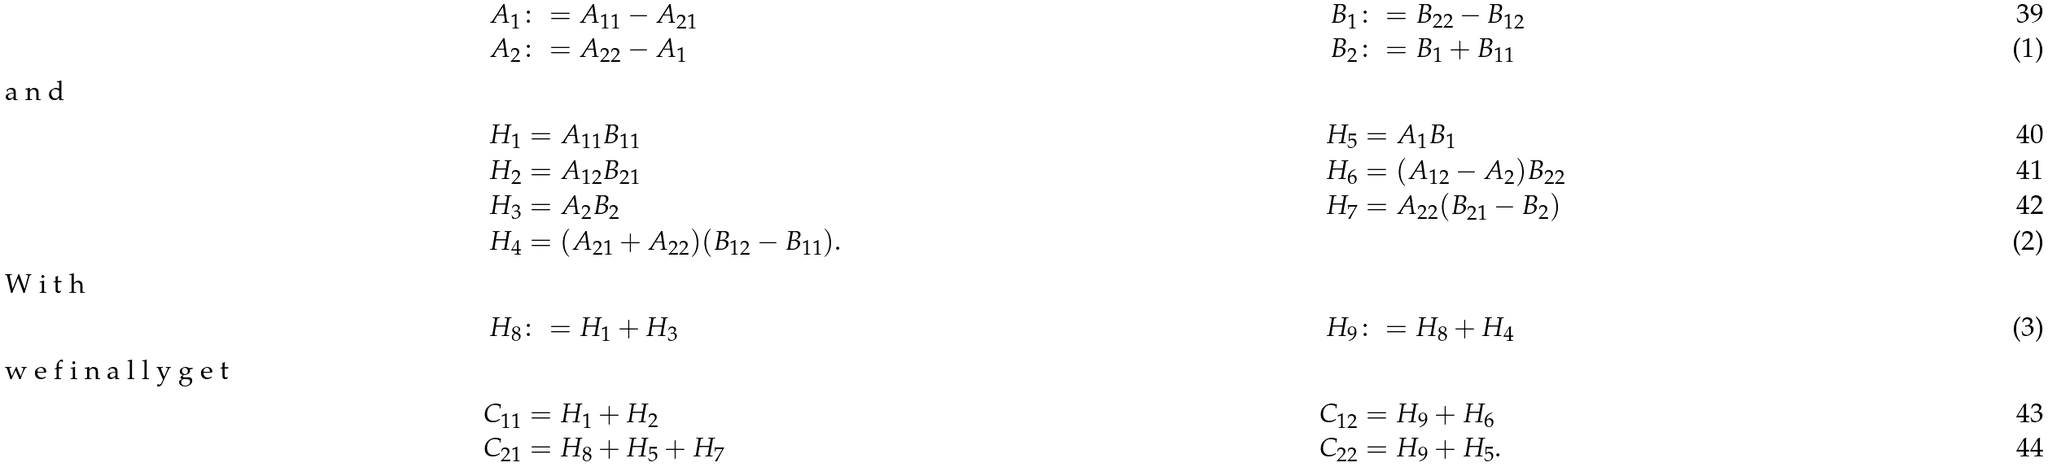Convert formula to latex. <formula><loc_0><loc_0><loc_500><loc_500>A _ { 1 } & \colon = A _ { 1 1 } - A _ { 2 1 } & B _ { 1 } & \colon = B _ { 2 2 } - B _ { 1 2 } \\ A _ { 2 } & \colon = A _ { 2 2 } - A _ { 1 } & B _ { 2 } & \colon = B _ { 1 } + B _ { 1 1 } \intertext { a n d } H _ { 1 } & = A _ { 1 1 } B _ { 1 1 } & H _ { 5 } & = A _ { 1 } B _ { 1 } \\ H _ { 2 } & = A _ { 1 2 } B _ { 2 1 } & H _ { 6 } & = ( A _ { 1 2 } - A _ { 2 } ) B _ { 2 2 } \\ H _ { 3 } & = A _ { 2 } B _ { 2 } & H _ { 7 } & = A _ { 2 2 } ( B _ { 2 1 } - B _ { 2 } ) \\ H _ { 4 } & = ( A _ { 2 1 } + A _ { 2 2 } ) ( B _ { 1 2 } - B _ { 1 1 } ) . \intertext { W i t h } H _ { 8 } & \colon = H _ { 1 } + H _ { 3 } & H _ { 9 } & \colon = H _ { 8 } + H _ { 4 } \intertext { w e f i n a l l y g e t } C _ { 1 1 } & = H _ { 1 } + H _ { 2 } & C _ { 1 2 } & = H _ { 9 } + H _ { 6 } \\ C _ { 2 1 } & = H _ { 8 } + H _ { 5 } + H _ { 7 } & C _ { 2 2 } & = H _ { 9 } + H _ { 5 } .</formula> 